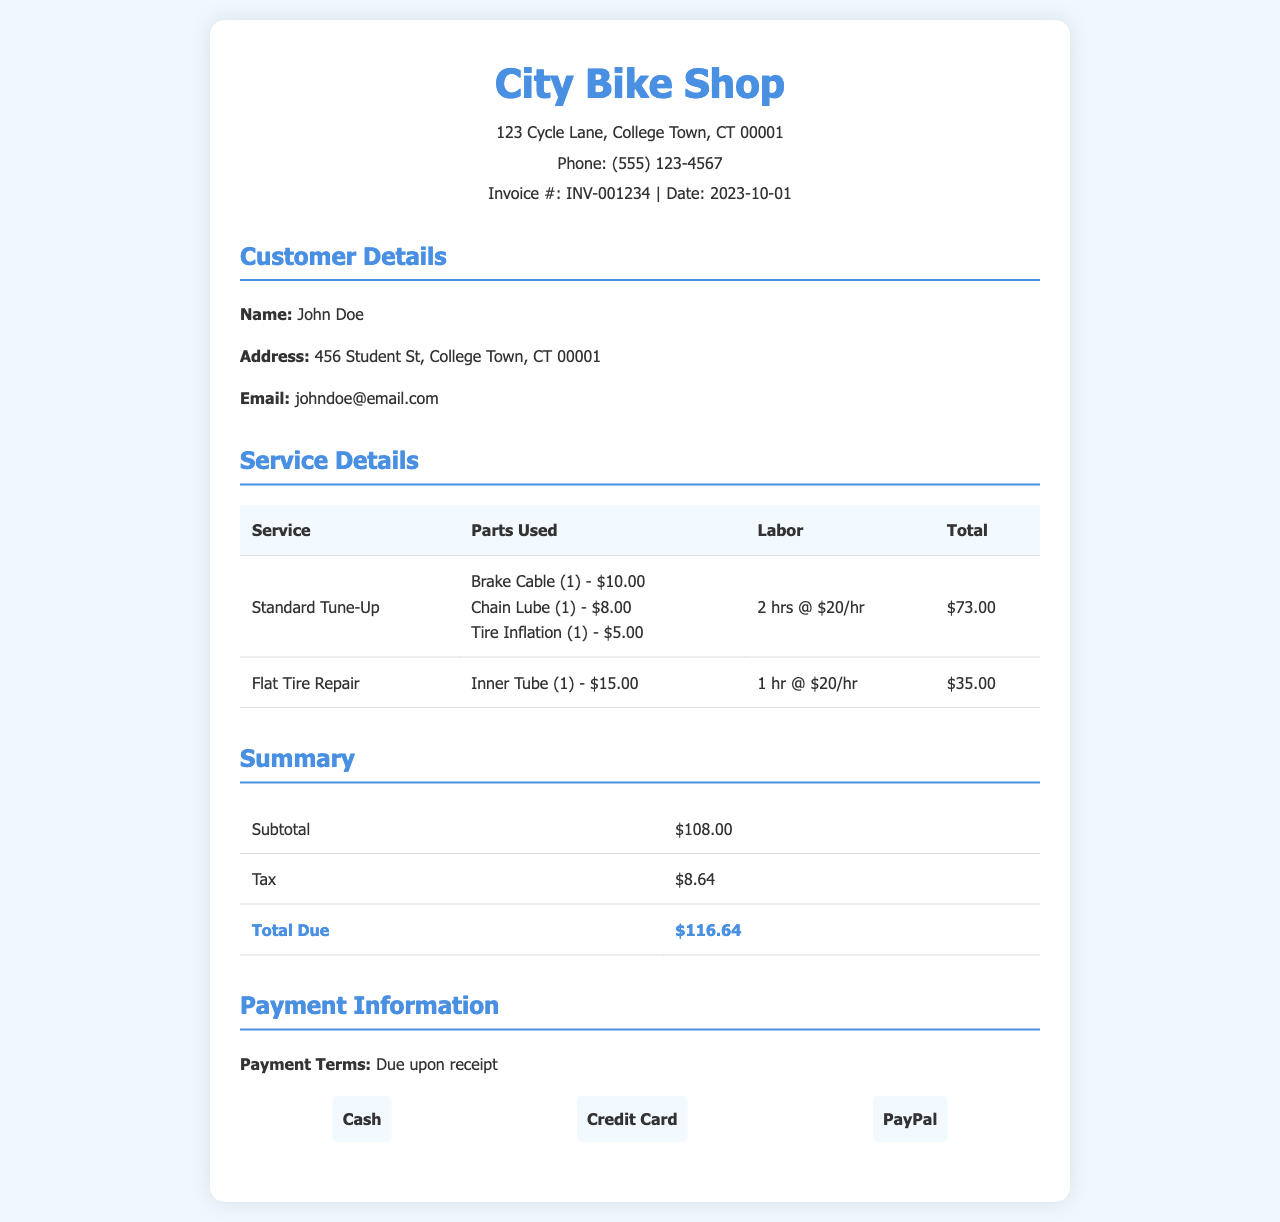What is the invoice date? The date of the invoice is clearly stated in the document.
Answer: 2023-10-01 What items were used for the Standard Tune-Up? The parts used in the Standard Tune-Up are listed in the service details table.
Answer: Brake Cable, Chain Lube, Tire Inflation What is the total amount due? The document summarizes the total due at the end of the invoice.
Answer: $116.64 How many hours of labor were charged for the Flat Tire Repair? The labor hours for each service are mentioned in the service details table.
Answer: 1 hr What is the name of the bike shop? The name of the bike shop is specified at the top of the invoice.
Answer: City Bike Shop How much did the Inner Tube cost? The price of the Inner Tube is listed under the parts used for the Flat Tire Repair.
Answer: $15.00 What is the subtotal before tax? The subtotal is provided in the summary section of the invoice.
Answer: $108.00 What is the payment term stated in the invoice? The payment terms are mentioned in the payment information section of the invoice.
Answer: Due upon receipt How much was charged per hour for labor? The labor cost per hour is stated alongside the hours worked for each service.
Answer: $20/hr 